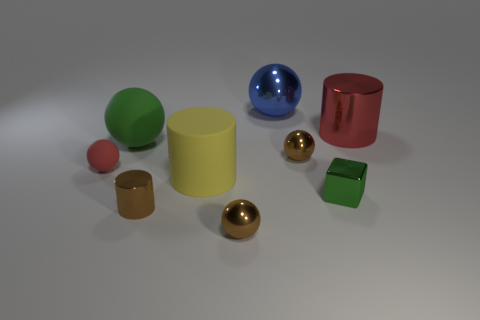What is the color of the big ball in front of the red cylinder?
Keep it short and to the point. Green. Are there more blue things that are behind the blue thing than small metallic things?
Offer a terse response. No. Do the tiny red thing and the large green object have the same material?
Offer a very short reply. Yes. What number of other objects are there of the same shape as the small rubber object?
Your answer should be compact. 4. There is a small ball on the right side of the sphere in front of the matte object that is in front of the small red object; what color is it?
Provide a succinct answer. Brown. Does the big rubber object in front of the tiny red object have the same shape as the blue thing?
Your answer should be very brief. No. How many rubber cylinders are there?
Make the answer very short. 1. What number of green things are the same size as the red matte sphere?
Your answer should be very brief. 1. What is the material of the red cylinder?
Provide a short and direct response. Metal. Does the small rubber object have the same color as the cylinder to the right of the large yellow cylinder?
Your answer should be very brief. Yes. 